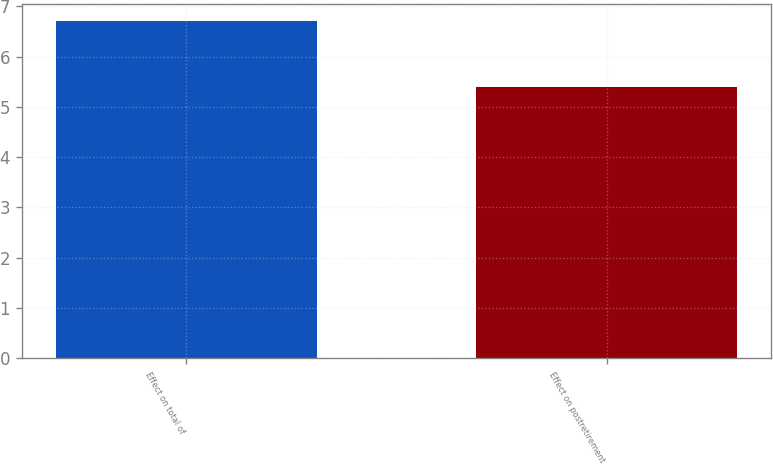<chart> <loc_0><loc_0><loc_500><loc_500><bar_chart><fcel>Effect on total of<fcel>Effect on postretirement<nl><fcel>6.7<fcel>5.4<nl></chart> 